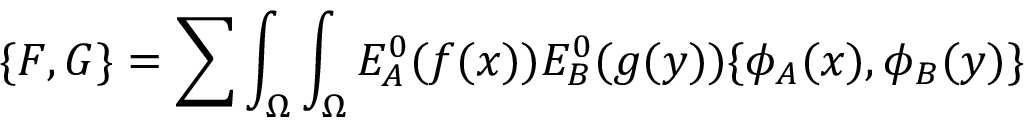Convert formula to latex. <formula><loc_0><loc_0><loc_500><loc_500>\{ F , G \} = \sum \int _ { \Omega } \int _ { \Omega } E _ { A } ^ { 0 } ( f ( x ) ) E _ { B } ^ { 0 } ( g ( y ) ) \{ \phi _ { A } ( x ) , \phi _ { B } ( y ) \}</formula> 